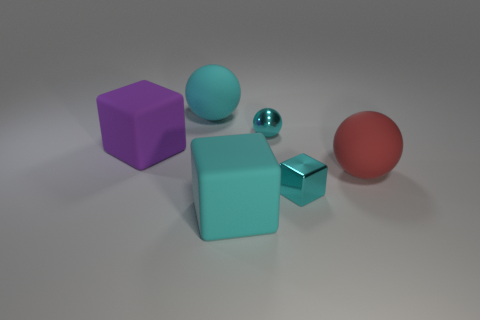Subtract all red spheres. Subtract all red cylinders. How many spheres are left? 2 Add 3 metal objects. How many objects exist? 9 Subtract all red balls. Subtract all purple rubber blocks. How many objects are left? 4 Add 2 tiny cyan metallic things. How many tiny cyan metallic things are left? 4 Add 3 big purple matte objects. How many big purple matte objects exist? 4 Subtract 0 cyan cylinders. How many objects are left? 6 